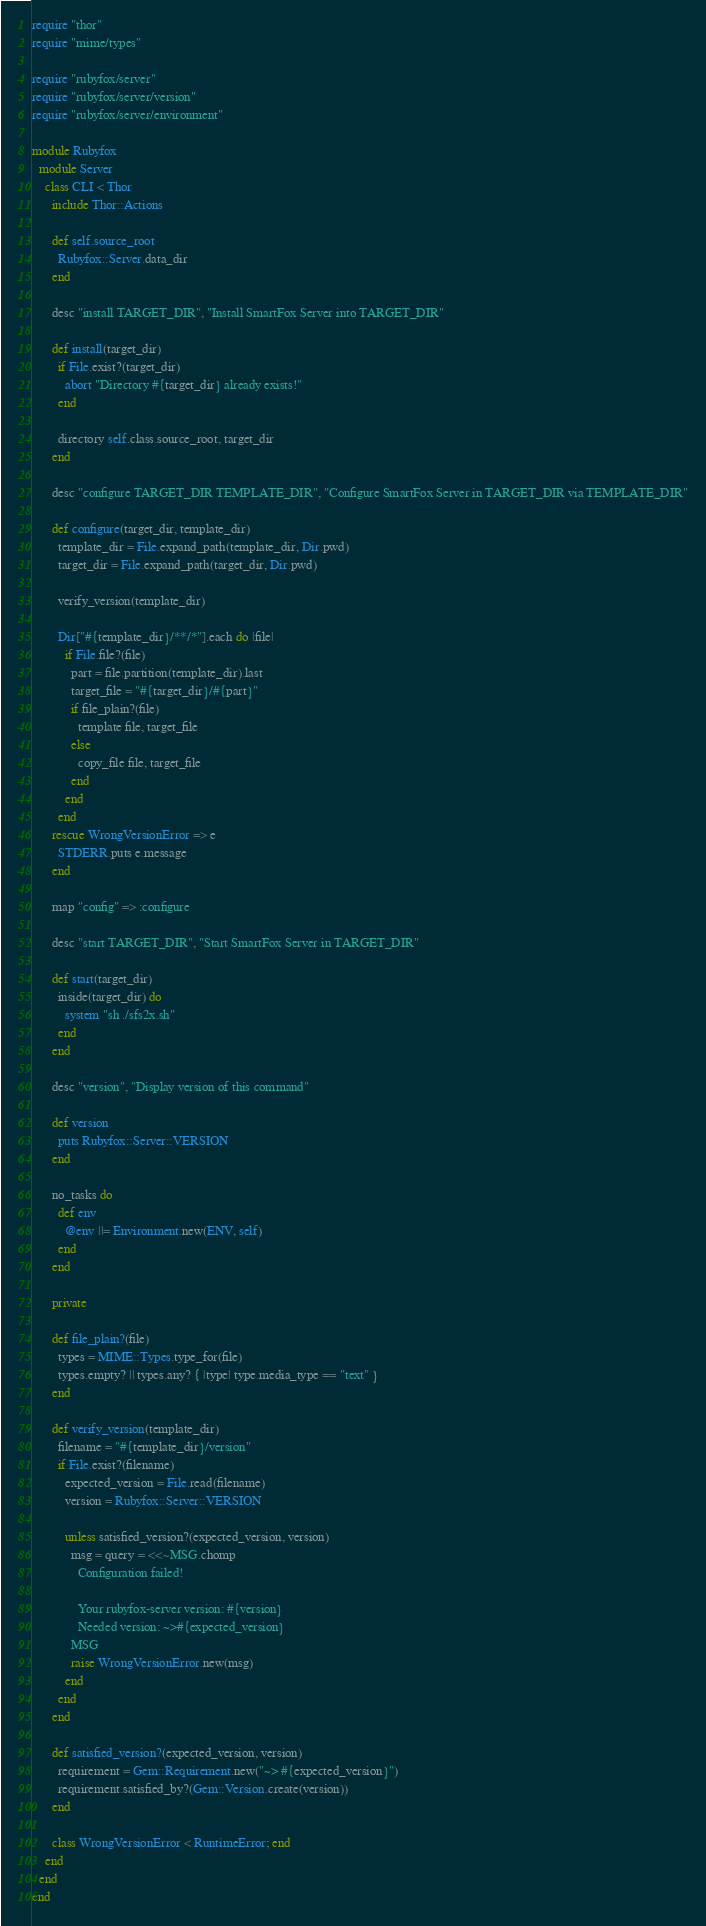<code> <loc_0><loc_0><loc_500><loc_500><_Ruby_>require "thor"
require "mime/types"

require "rubyfox/server"
require "rubyfox/server/version"
require "rubyfox/server/environment"

module Rubyfox
  module Server
    class CLI < Thor
      include Thor::Actions

      def self.source_root
        Rubyfox::Server.data_dir
      end

      desc "install TARGET_DIR", "Install SmartFox Server into TARGET_DIR"

      def install(target_dir)
        if File.exist?(target_dir)
          abort "Directory #{target_dir} already exists!"
        end

        directory self.class.source_root, target_dir
      end

      desc "configure TARGET_DIR TEMPLATE_DIR", "Configure SmartFox Server in TARGET_DIR via TEMPLATE_DIR"

      def configure(target_dir, template_dir)
        template_dir = File.expand_path(template_dir, Dir.pwd)
        target_dir = File.expand_path(target_dir, Dir.pwd)

        verify_version(template_dir)

        Dir["#{template_dir}/**/*"].each do |file|
          if File.file?(file)
            part = file.partition(template_dir).last
            target_file = "#{target_dir}/#{part}"
            if file_plain?(file)
              template file, target_file
            else
              copy_file file, target_file
            end
          end
        end
      rescue WrongVersionError => e
        STDERR.puts e.message
      end

      map "config" => :configure

      desc "start TARGET_DIR", "Start SmartFox Server in TARGET_DIR"

      def start(target_dir)
        inside(target_dir) do
          system "sh ./sfs2x.sh"
        end
      end

      desc "version", "Display version of this command"

      def version
        puts Rubyfox::Server::VERSION
      end

      no_tasks do
        def env
          @env ||= Environment.new(ENV, self)
        end
      end

      private

      def file_plain?(file)
        types = MIME::Types.type_for(file)
        types.empty? || types.any? { |type| type.media_type == "text" }
      end

      def verify_version(template_dir)
        filename = "#{template_dir}/version"
        if File.exist?(filename)
          expected_version = File.read(filename)
          version = Rubyfox::Server::VERSION

          unless satisfied_version?(expected_version, version)
            msg = query = <<~MSG.chomp
              Configuration failed!

              Your rubyfox-server version: #{version}
              Needed version: ~>#{expected_version}
            MSG
            raise WrongVersionError.new(msg)
          end
        end
      end

      def satisfied_version?(expected_version, version)
        requirement = Gem::Requirement.new("~> #{expected_version}")
        requirement.satisfied_by?(Gem::Version.create(version))
      end

      class WrongVersionError < RuntimeError; end
    end
  end
end
</code> 